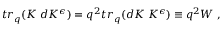<formula> <loc_0><loc_0><loc_500><loc_500>t r _ { q } ( K \, d K ^ { \epsilon } ) = q ^ { 2 } t r _ { q } ( d K \, K ^ { \epsilon } ) \equiv q ^ { 2 } W \, ,</formula> 